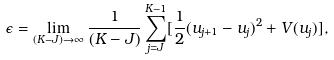Convert formula to latex. <formula><loc_0><loc_0><loc_500><loc_500>\epsilon = \lim _ { ( K - J ) \rightarrow \infty } \frac { 1 } { ( K - J ) } \sum _ { j = J } ^ { K - 1 } [ \frac { 1 } { 2 } ( u _ { j + 1 } - u _ { j } ) ^ { 2 } + V ( u _ { j } ) ] ,</formula> 